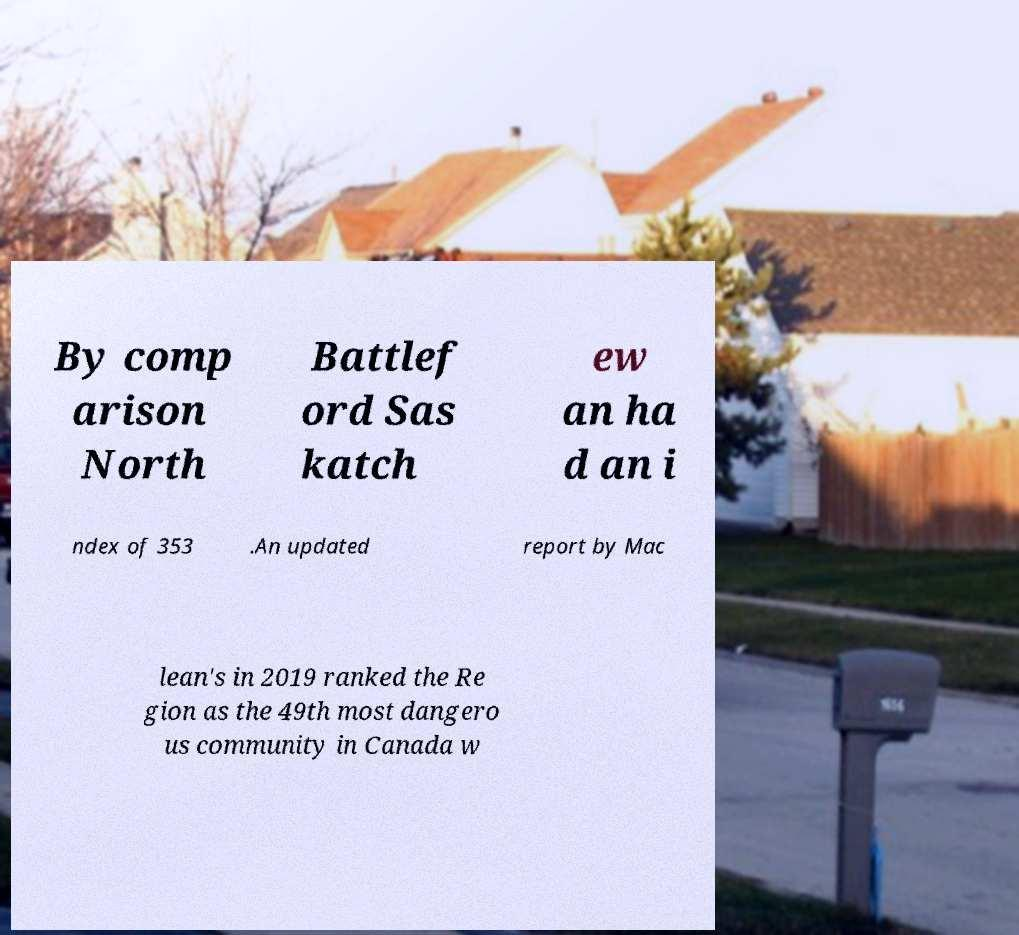I need the written content from this picture converted into text. Can you do that? By comp arison North Battlef ord Sas katch ew an ha d an i ndex of 353 .An updated report by Mac lean's in 2019 ranked the Re gion as the 49th most dangero us community in Canada w 